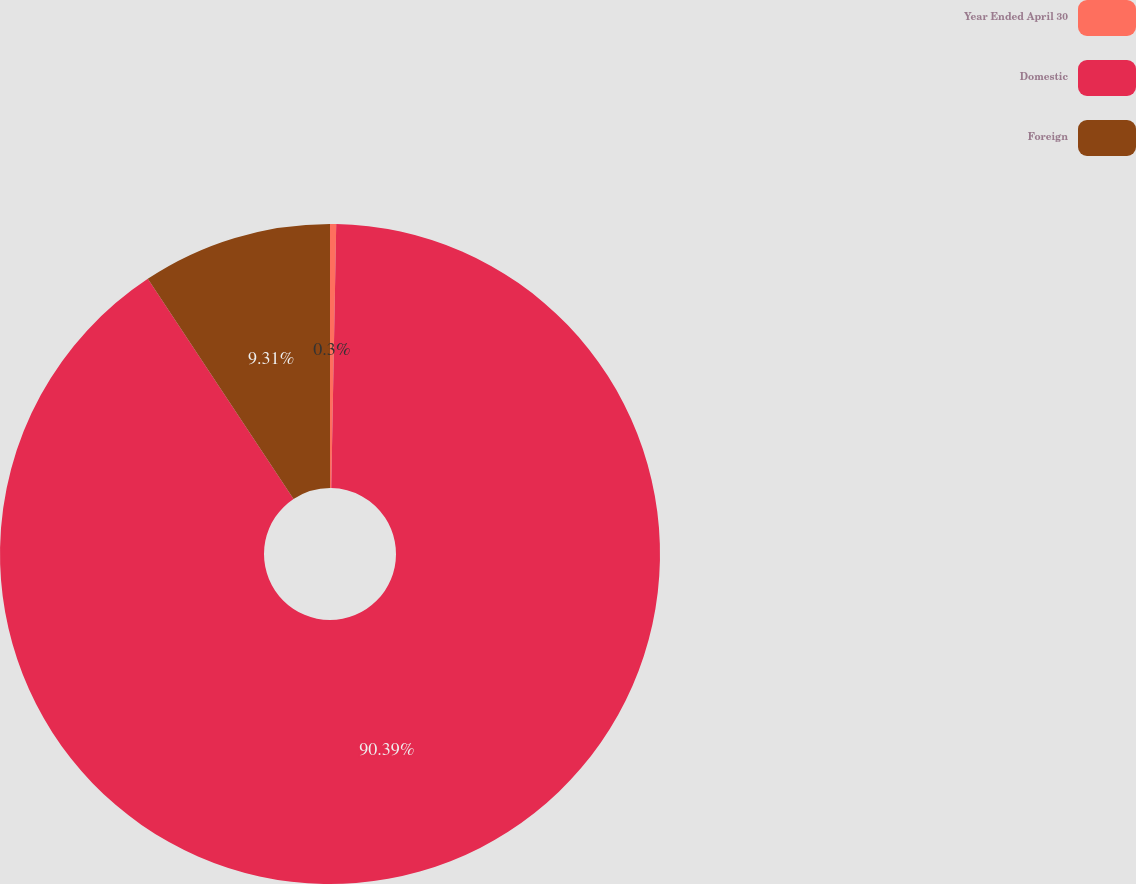Convert chart to OTSL. <chart><loc_0><loc_0><loc_500><loc_500><pie_chart><fcel>Year Ended April 30<fcel>Domestic<fcel>Foreign<nl><fcel>0.3%<fcel>90.39%<fcel>9.31%<nl></chart> 